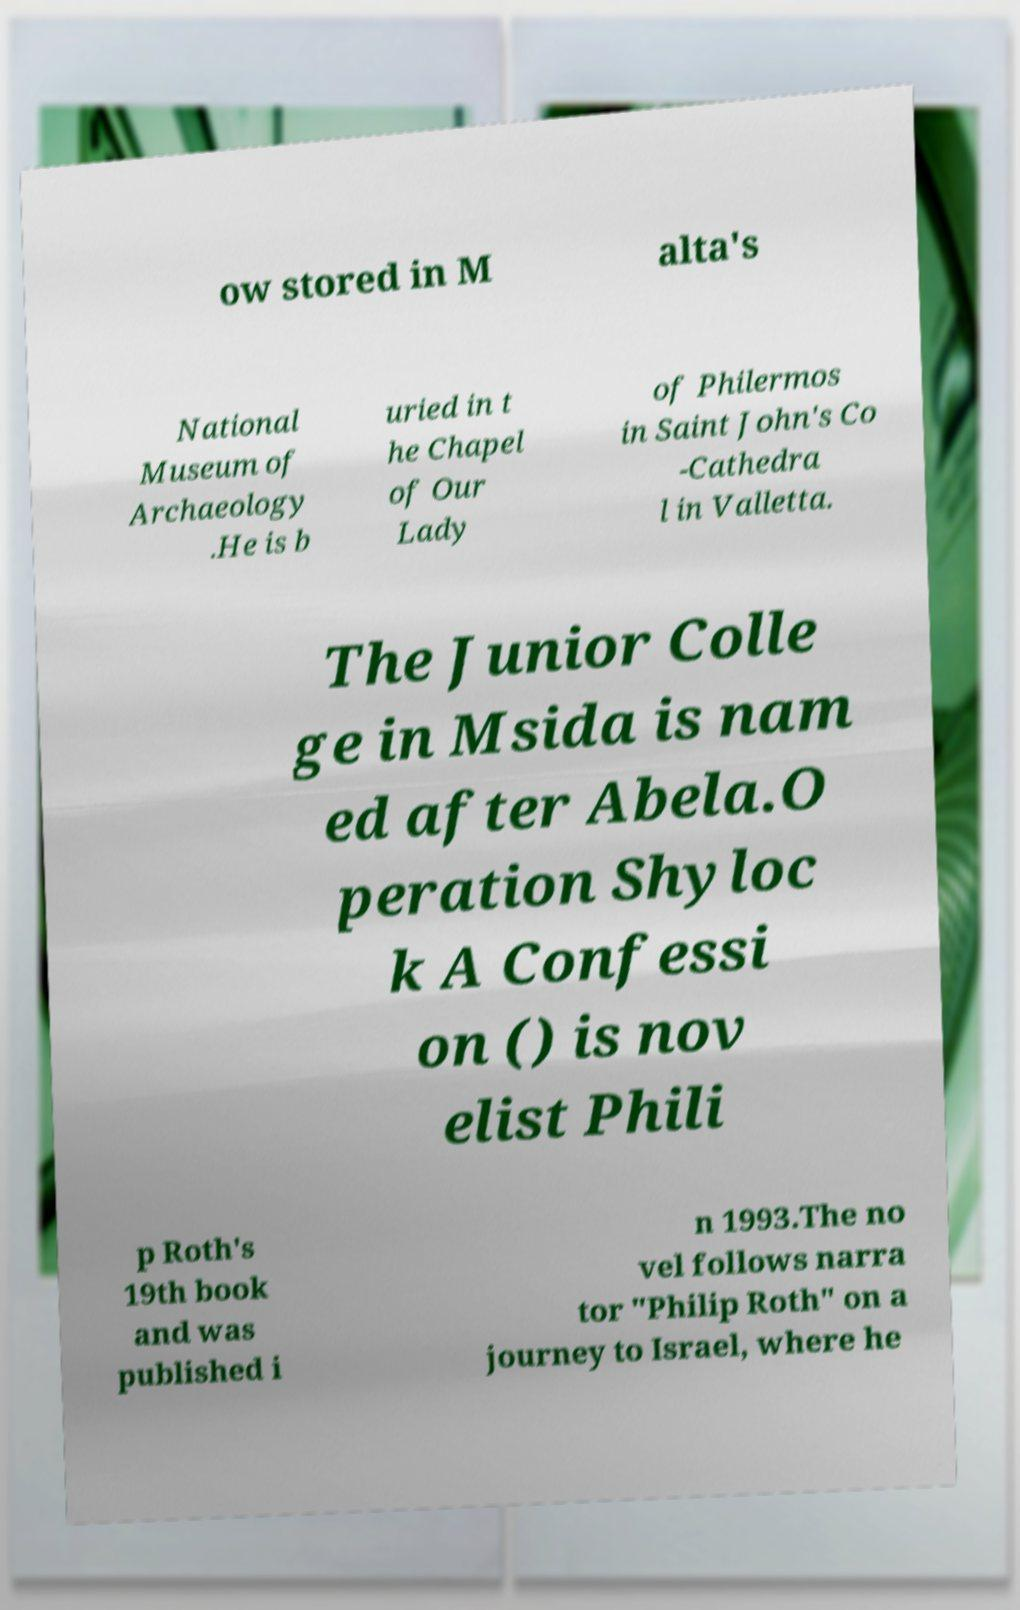What messages or text are displayed in this image? I need them in a readable, typed format. ow stored in M alta's National Museum of Archaeology .He is b uried in t he Chapel of Our Lady of Philermos in Saint John's Co -Cathedra l in Valletta. The Junior Colle ge in Msida is nam ed after Abela.O peration Shyloc k A Confessi on () is nov elist Phili p Roth's 19th book and was published i n 1993.The no vel follows narra tor "Philip Roth" on a journey to Israel, where he 